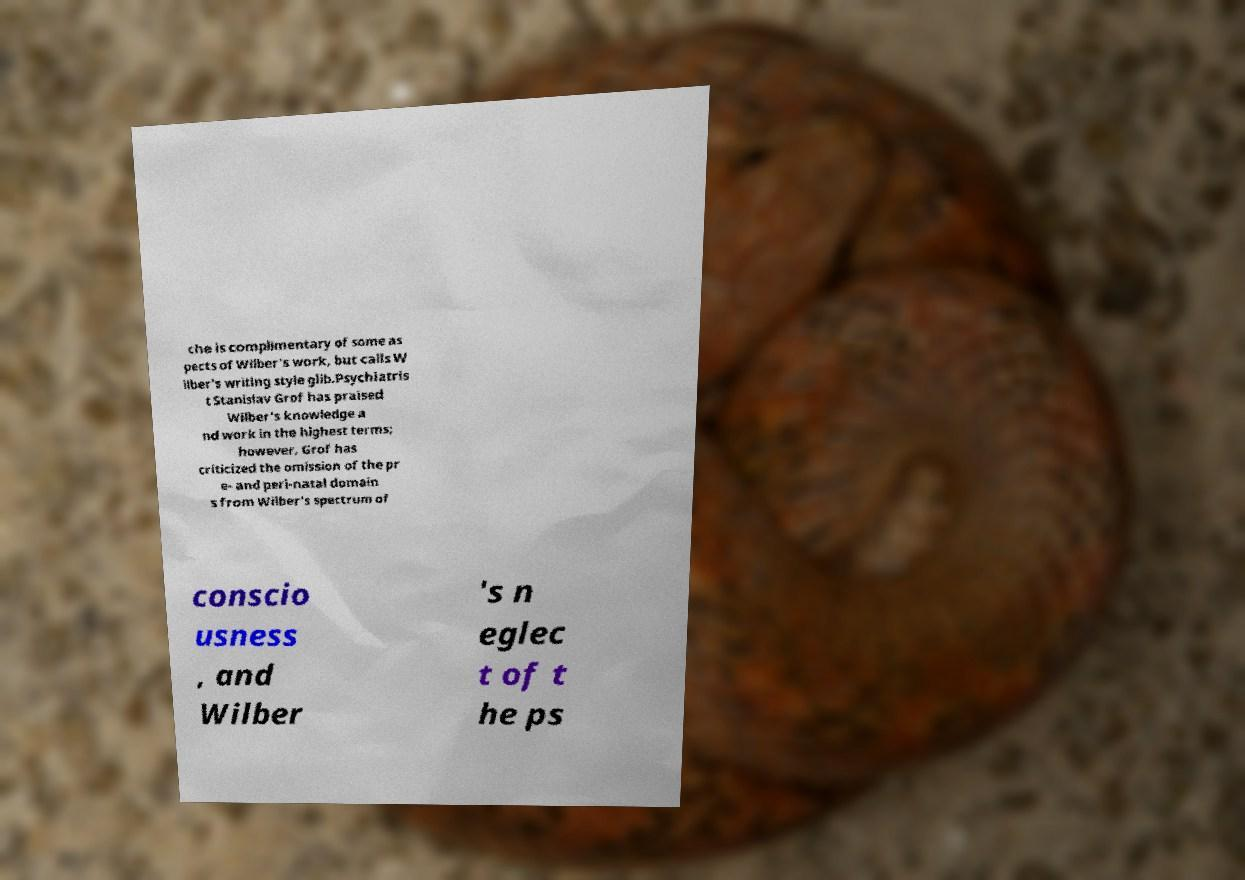Can you read and provide the text displayed in the image?This photo seems to have some interesting text. Can you extract and type it out for me? che is complimentary of some as pects of Wilber's work, but calls W ilber's writing style glib.Psychiatris t Stanislav Grof has praised Wilber's knowledge a nd work in the highest terms; however, Grof has criticized the omission of the pr e- and peri-natal domain s from Wilber's spectrum of conscio usness , and Wilber 's n eglec t of t he ps 